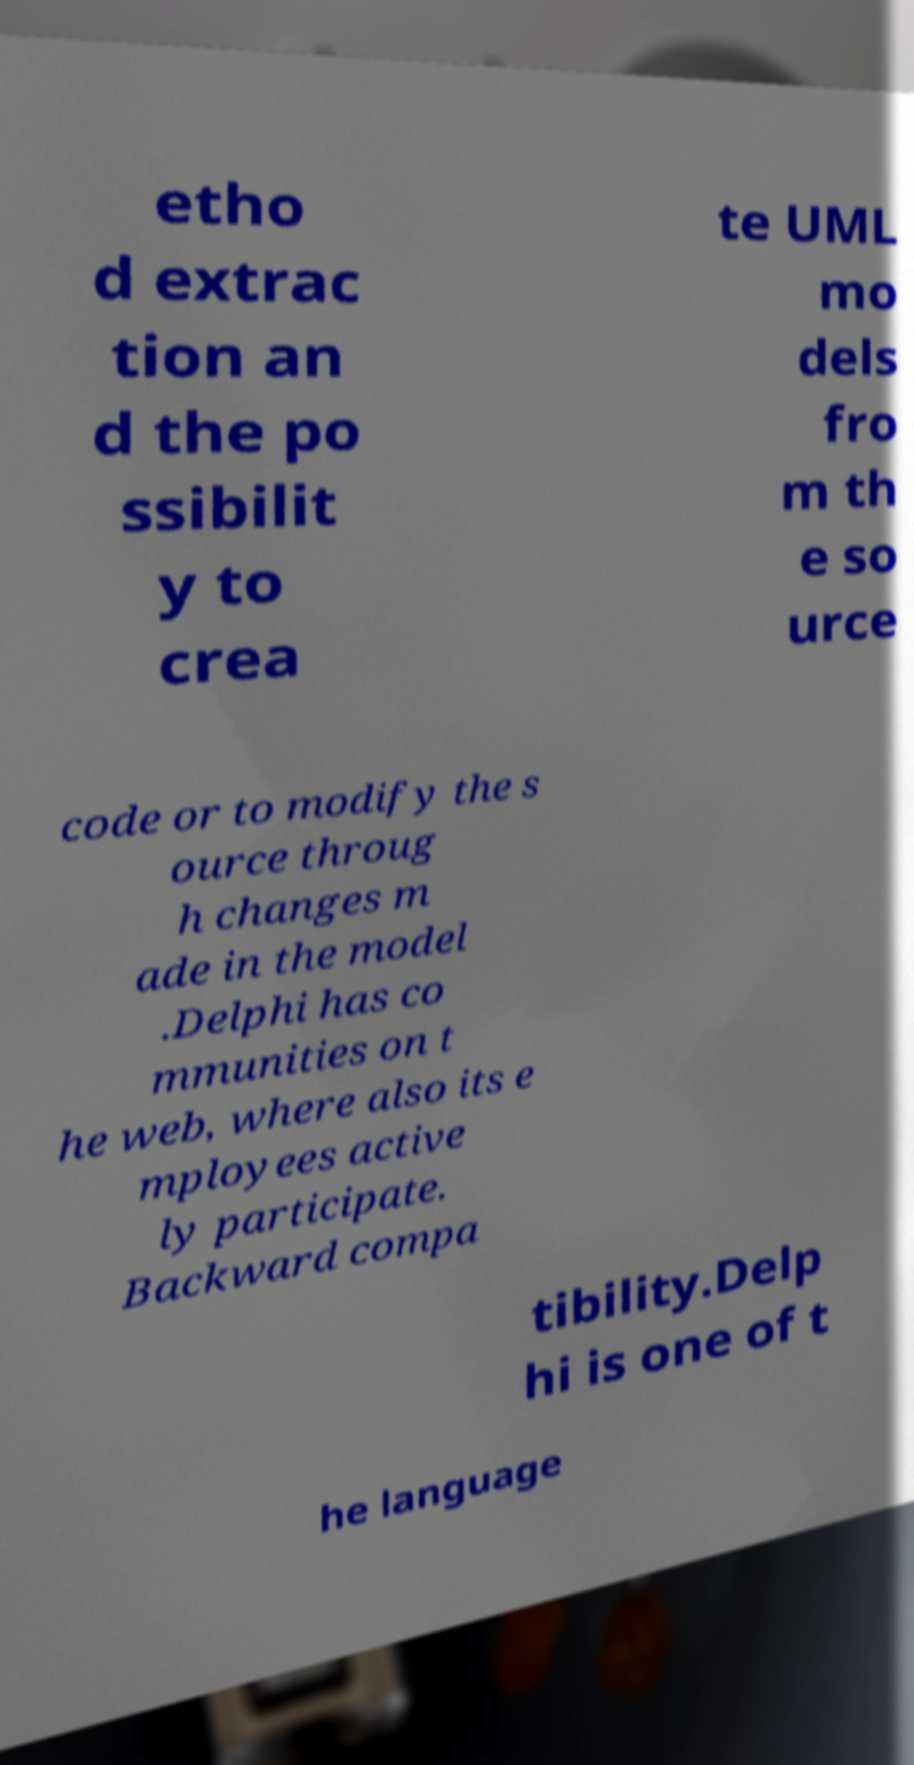Please read and relay the text visible in this image. What does it say? etho d extrac tion an d the po ssibilit y to crea te UML mo dels fro m th e so urce code or to modify the s ource throug h changes m ade in the model .Delphi has co mmunities on t he web, where also its e mployees active ly participate. Backward compa tibility.Delp hi is one of t he language 